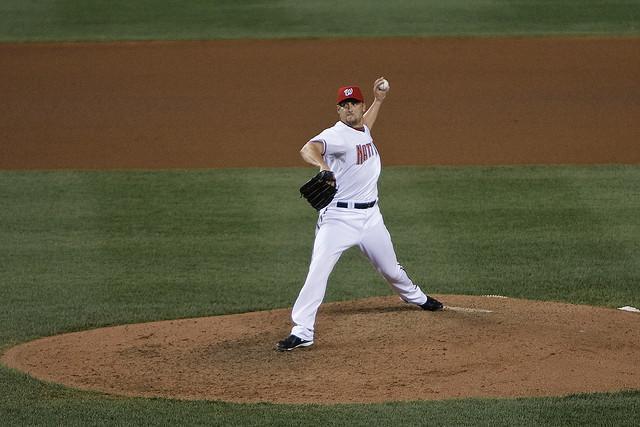How many players are in this photo?
Give a very brief answer. 1. How many dogs are on he bench in this image?
Give a very brief answer. 0. 